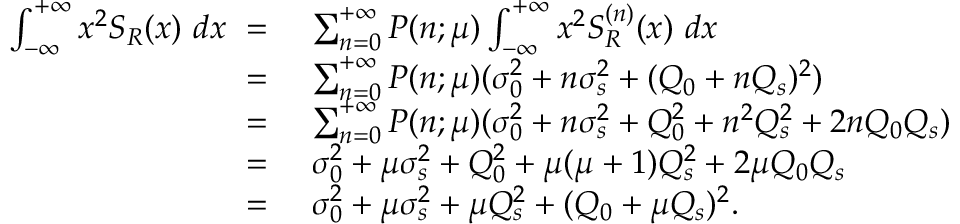Convert formula to latex. <formula><loc_0><loc_0><loc_500><loc_500>\begin{array} { r l } { \int _ { - \infty } ^ { + \infty } x ^ { 2 } S _ { R } ( x ) \ d x \ = } & { \ \sum _ { n = 0 } ^ { + \infty } P ( n ; \mu ) \int _ { - \infty } ^ { + \infty } x ^ { 2 } S _ { R } ^ { ( n ) } ( x ) \ d x } \\ { \ = } & { \ \sum _ { n = 0 } ^ { + \infty } P ( n ; \mu ) ( \sigma _ { 0 } ^ { 2 } + n \sigma _ { s } ^ { 2 } + ( Q _ { 0 } + n Q _ { s } ) ^ { 2 } ) } \\ { \ = } & { \ \sum _ { n = 0 } ^ { + \infty } P ( n ; \mu ) ( \sigma _ { 0 } ^ { 2 } + n \sigma _ { s } ^ { 2 } + Q _ { 0 } ^ { 2 } + n ^ { 2 } Q _ { s } ^ { 2 } + 2 n Q _ { 0 } Q _ { s } ) } \\ { \ = } & { \ \sigma _ { 0 } ^ { 2 } + \mu \sigma _ { s } ^ { 2 } + Q _ { 0 } ^ { 2 } + \mu ( \mu + 1 ) Q _ { s } ^ { 2 } + 2 \mu Q _ { 0 } Q _ { s } } \\ { \ = } & { \ \sigma _ { 0 } ^ { 2 } + \mu \sigma _ { s } ^ { 2 } + \mu Q _ { s } ^ { 2 } + ( Q _ { 0 } + \mu Q _ { s } ) ^ { 2 } . } \end{array}</formula> 